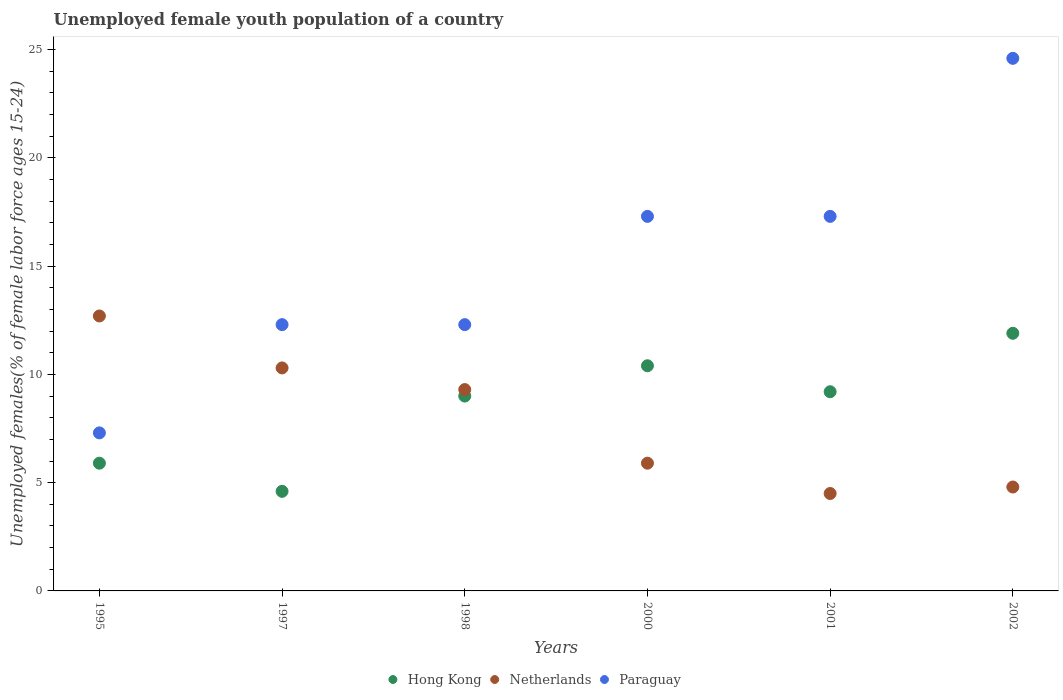How many different coloured dotlines are there?
Give a very brief answer. 3. Is the number of dotlines equal to the number of legend labels?
Give a very brief answer. Yes. Across all years, what is the maximum percentage of unemployed female youth population in Netherlands?
Your answer should be compact. 12.7. Across all years, what is the minimum percentage of unemployed female youth population in Hong Kong?
Make the answer very short. 4.6. What is the total percentage of unemployed female youth population in Hong Kong in the graph?
Provide a short and direct response. 51. What is the difference between the percentage of unemployed female youth population in Hong Kong in 1998 and that in 2001?
Provide a short and direct response. -0.2. What is the difference between the percentage of unemployed female youth population in Paraguay in 1997 and the percentage of unemployed female youth population in Hong Kong in 2001?
Make the answer very short. 3.1. What is the average percentage of unemployed female youth population in Hong Kong per year?
Keep it short and to the point. 8.5. In the year 1998, what is the difference between the percentage of unemployed female youth population in Hong Kong and percentage of unemployed female youth population in Paraguay?
Keep it short and to the point. -3.3. What is the ratio of the percentage of unemployed female youth population in Paraguay in 1998 to that in 2001?
Your answer should be very brief. 0.71. Is the percentage of unemployed female youth population in Hong Kong in 1998 less than that in 2001?
Your answer should be compact. Yes. Is the difference between the percentage of unemployed female youth population in Hong Kong in 1998 and 2000 greater than the difference between the percentage of unemployed female youth population in Paraguay in 1998 and 2000?
Keep it short and to the point. Yes. What is the difference between the highest and the second highest percentage of unemployed female youth population in Paraguay?
Offer a terse response. 7.3. What is the difference between the highest and the lowest percentage of unemployed female youth population in Hong Kong?
Your response must be concise. 7.3. In how many years, is the percentage of unemployed female youth population in Hong Kong greater than the average percentage of unemployed female youth population in Hong Kong taken over all years?
Provide a succinct answer. 4. Is the sum of the percentage of unemployed female youth population in Paraguay in 2001 and 2002 greater than the maximum percentage of unemployed female youth population in Netherlands across all years?
Give a very brief answer. Yes. Is it the case that in every year, the sum of the percentage of unemployed female youth population in Paraguay and percentage of unemployed female youth population in Hong Kong  is greater than the percentage of unemployed female youth population in Netherlands?
Your response must be concise. Yes. Is the percentage of unemployed female youth population in Hong Kong strictly greater than the percentage of unemployed female youth population in Paraguay over the years?
Offer a very short reply. No. How many years are there in the graph?
Provide a succinct answer. 6. Does the graph contain any zero values?
Provide a succinct answer. No. Does the graph contain grids?
Provide a short and direct response. No. Where does the legend appear in the graph?
Make the answer very short. Bottom center. How many legend labels are there?
Keep it short and to the point. 3. How are the legend labels stacked?
Give a very brief answer. Horizontal. What is the title of the graph?
Provide a succinct answer. Unemployed female youth population of a country. What is the label or title of the X-axis?
Provide a succinct answer. Years. What is the label or title of the Y-axis?
Your response must be concise. Unemployed females(% of female labor force ages 15-24). What is the Unemployed females(% of female labor force ages 15-24) in Hong Kong in 1995?
Keep it short and to the point. 5.9. What is the Unemployed females(% of female labor force ages 15-24) in Netherlands in 1995?
Provide a short and direct response. 12.7. What is the Unemployed females(% of female labor force ages 15-24) in Paraguay in 1995?
Your answer should be compact. 7.3. What is the Unemployed females(% of female labor force ages 15-24) of Hong Kong in 1997?
Your response must be concise. 4.6. What is the Unemployed females(% of female labor force ages 15-24) in Netherlands in 1997?
Keep it short and to the point. 10.3. What is the Unemployed females(% of female labor force ages 15-24) of Paraguay in 1997?
Provide a succinct answer. 12.3. What is the Unemployed females(% of female labor force ages 15-24) in Netherlands in 1998?
Your answer should be compact. 9.3. What is the Unemployed females(% of female labor force ages 15-24) of Paraguay in 1998?
Offer a terse response. 12.3. What is the Unemployed females(% of female labor force ages 15-24) in Hong Kong in 2000?
Your answer should be very brief. 10.4. What is the Unemployed females(% of female labor force ages 15-24) of Netherlands in 2000?
Your response must be concise. 5.9. What is the Unemployed females(% of female labor force ages 15-24) of Paraguay in 2000?
Your answer should be compact. 17.3. What is the Unemployed females(% of female labor force ages 15-24) of Hong Kong in 2001?
Make the answer very short. 9.2. What is the Unemployed females(% of female labor force ages 15-24) of Netherlands in 2001?
Keep it short and to the point. 4.5. What is the Unemployed females(% of female labor force ages 15-24) of Paraguay in 2001?
Make the answer very short. 17.3. What is the Unemployed females(% of female labor force ages 15-24) in Hong Kong in 2002?
Your response must be concise. 11.9. What is the Unemployed females(% of female labor force ages 15-24) in Netherlands in 2002?
Make the answer very short. 4.8. What is the Unemployed females(% of female labor force ages 15-24) in Paraguay in 2002?
Offer a terse response. 24.6. Across all years, what is the maximum Unemployed females(% of female labor force ages 15-24) of Hong Kong?
Give a very brief answer. 11.9. Across all years, what is the maximum Unemployed females(% of female labor force ages 15-24) in Netherlands?
Provide a succinct answer. 12.7. Across all years, what is the maximum Unemployed females(% of female labor force ages 15-24) in Paraguay?
Give a very brief answer. 24.6. Across all years, what is the minimum Unemployed females(% of female labor force ages 15-24) in Hong Kong?
Make the answer very short. 4.6. Across all years, what is the minimum Unemployed females(% of female labor force ages 15-24) in Netherlands?
Provide a succinct answer. 4.5. Across all years, what is the minimum Unemployed females(% of female labor force ages 15-24) of Paraguay?
Give a very brief answer. 7.3. What is the total Unemployed females(% of female labor force ages 15-24) of Hong Kong in the graph?
Your answer should be compact. 51. What is the total Unemployed females(% of female labor force ages 15-24) in Netherlands in the graph?
Give a very brief answer. 47.5. What is the total Unemployed females(% of female labor force ages 15-24) in Paraguay in the graph?
Offer a very short reply. 91.1. What is the difference between the Unemployed females(% of female labor force ages 15-24) in Hong Kong in 1995 and that in 1997?
Your answer should be compact. 1.3. What is the difference between the Unemployed females(% of female labor force ages 15-24) in Netherlands in 1995 and that in 1997?
Make the answer very short. 2.4. What is the difference between the Unemployed females(% of female labor force ages 15-24) of Paraguay in 1995 and that in 1997?
Offer a very short reply. -5. What is the difference between the Unemployed females(% of female labor force ages 15-24) in Hong Kong in 1995 and that in 1998?
Give a very brief answer. -3.1. What is the difference between the Unemployed females(% of female labor force ages 15-24) in Hong Kong in 1995 and that in 2000?
Your response must be concise. -4.5. What is the difference between the Unemployed females(% of female labor force ages 15-24) of Netherlands in 1995 and that in 2000?
Keep it short and to the point. 6.8. What is the difference between the Unemployed females(% of female labor force ages 15-24) in Hong Kong in 1995 and that in 2001?
Keep it short and to the point. -3.3. What is the difference between the Unemployed females(% of female labor force ages 15-24) of Hong Kong in 1995 and that in 2002?
Your answer should be very brief. -6. What is the difference between the Unemployed females(% of female labor force ages 15-24) of Netherlands in 1995 and that in 2002?
Provide a succinct answer. 7.9. What is the difference between the Unemployed females(% of female labor force ages 15-24) in Paraguay in 1995 and that in 2002?
Offer a very short reply. -17.3. What is the difference between the Unemployed females(% of female labor force ages 15-24) in Hong Kong in 1997 and that in 1998?
Offer a very short reply. -4.4. What is the difference between the Unemployed females(% of female labor force ages 15-24) of Hong Kong in 1997 and that in 2001?
Offer a very short reply. -4.6. What is the difference between the Unemployed females(% of female labor force ages 15-24) in Netherlands in 1998 and that in 2000?
Your answer should be very brief. 3.4. What is the difference between the Unemployed females(% of female labor force ages 15-24) in Paraguay in 1998 and that in 2000?
Ensure brevity in your answer.  -5. What is the difference between the Unemployed females(% of female labor force ages 15-24) in Hong Kong in 1998 and that in 2001?
Offer a very short reply. -0.2. What is the difference between the Unemployed females(% of female labor force ages 15-24) in Netherlands in 1998 and that in 2001?
Make the answer very short. 4.8. What is the difference between the Unemployed females(% of female labor force ages 15-24) in Paraguay in 1998 and that in 2002?
Provide a short and direct response. -12.3. What is the difference between the Unemployed females(% of female labor force ages 15-24) in Hong Kong in 2000 and that in 2001?
Keep it short and to the point. 1.2. What is the difference between the Unemployed females(% of female labor force ages 15-24) in Paraguay in 2000 and that in 2001?
Provide a succinct answer. 0. What is the difference between the Unemployed females(% of female labor force ages 15-24) of Hong Kong in 2000 and that in 2002?
Provide a short and direct response. -1.5. What is the difference between the Unemployed females(% of female labor force ages 15-24) in Netherlands in 2000 and that in 2002?
Provide a short and direct response. 1.1. What is the difference between the Unemployed females(% of female labor force ages 15-24) in Paraguay in 2000 and that in 2002?
Your response must be concise. -7.3. What is the difference between the Unemployed females(% of female labor force ages 15-24) of Hong Kong in 1995 and the Unemployed females(% of female labor force ages 15-24) of Netherlands in 1997?
Make the answer very short. -4.4. What is the difference between the Unemployed females(% of female labor force ages 15-24) of Hong Kong in 1995 and the Unemployed females(% of female labor force ages 15-24) of Paraguay in 1997?
Your response must be concise. -6.4. What is the difference between the Unemployed females(% of female labor force ages 15-24) of Hong Kong in 1995 and the Unemployed females(% of female labor force ages 15-24) of Netherlands in 1998?
Ensure brevity in your answer.  -3.4. What is the difference between the Unemployed females(% of female labor force ages 15-24) of Hong Kong in 1995 and the Unemployed females(% of female labor force ages 15-24) of Paraguay in 1998?
Your response must be concise. -6.4. What is the difference between the Unemployed females(% of female labor force ages 15-24) of Hong Kong in 1995 and the Unemployed females(% of female labor force ages 15-24) of Paraguay in 2000?
Your response must be concise. -11.4. What is the difference between the Unemployed females(% of female labor force ages 15-24) of Hong Kong in 1995 and the Unemployed females(% of female labor force ages 15-24) of Paraguay in 2001?
Make the answer very short. -11.4. What is the difference between the Unemployed females(% of female labor force ages 15-24) of Hong Kong in 1995 and the Unemployed females(% of female labor force ages 15-24) of Paraguay in 2002?
Offer a terse response. -18.7. What is the difference between the Unemployed females(% of female labor force ages 15-24) in Netherlands in 1995 and the Unemployed females(% of female labor force ages 15-24) in Paraguay in 2002?
Offer a terse response. -11.9. What is the difference between the Unemployed females(% of female labor force ages 15-24) of Hong Kong in 1997 and the Unemployed females(% of female labor force ages 15-24) of Netherlands in 2000?
Make the answer very short. -1.3. What is the difference between the Unemployed females(% of female labor force ages 15-24) in Hong Kong in 1997 and the Unemployed females(% of female labor force ages 15-24) in Netherlands in 2001?
Your response must be concise. 0.1. What is the difference between the Unemployed females(% of female labor force ages 15-24) of Hong Kong in 1997 and the Unemployed females(% of female labor force ages 15-24) of Paraguay in 2001?
Your response must be concise. -12.7. What is the difference between the Unemployed females(% of female labor force ages 15-24) of Netherlands in 1997 and the Unemployed females(% of female labor force ages 15-24) of Paraguay in 2001?
Provide a succinct answer. -7. What is the difference between the Unemployed females(% of female labor force ages 15-24) of Hong Kong in 1997 and the Unemployed females(% of female labor force ages 15-24) of Netherlands in 2002?
Ensure brevity in your answer.  -0.2. What is the difference between the Unemployed females(% of female labor force ages 15-24) of Netherlands in 1997 and the Unemployed females(% of female labor force ages 15-24) of Paraguay in 2002?
Ensure brevity in your answer.  -14.3. What is the difference between the Unemployed females(% of female labor force ages 15-24) in Hong Kong in 1998 and the Unemployed females(% of female labor force ages 15-24) in Netherlands in 2000?
Provide a succinct answer. 3.1. What is the difference between the Unemployed females(% of female labor force ages 15-24) in Hong Kong in 1998 and the Unemployed females(% of female labor force ages 15-24) in Paraguay in 2000?
Offer a terse response. -8.3. What is the difference between the Unemployed females(% of female labor force ages 15-24) of Netherlands in 1998 and the Unemployed females(% of female labor force ages 15-24) of Paraguay in 2000?
Offer a very short reply. -8. What is the difference between the Unemployed females(% of female labor force ages 15-24) of Hong Kong in 1998 and the Unemployed females(% of female labor force ages 15-24) of Netherlands in 2001?
Provide a short and direct response. 4.5. What is the difference between the Unemployed females(% of female labor force ages 15-24) in Netherlands in 1998 and the Unemployed females(% of female labor force ages 15-24) in Paraguay in 2001?
Your answer should be very brief. -8. What is the difference between the Unemployed females(% of female labor force ages 15-24) in Hong Kong in 1998 and the Unemployed females(% of female labor force ages 15-24) in Paraguay in 2002?
Your answer should be compact. -15.6. What is the difference between the Unemployed females(% of female labor force ages 15-24) in Netherlands in 1998 and the Unemployed females(% of female labor force ages 15-24) in Paraguay in 2002?
Make the answer very short. -15.3. What is the difference between the Unemployed females(% of female labor force ages 15-24) of Hong Kong in 2000 and the Unemployed females(% of female labor force ages 15-24) of Netherlands in 2001?
Your response must be concise. 5.9. What is the difference between the Unemployed females(% of female labor force ages 15-24) of Netherlands in 2000 and the Unemployed females(% of female labor force ages 15-24) of Paraguay in 2001?
Keep it short and to the point. -11.4. What is the difference between the Unemployed females(% of female labor force ages 15-24) in Hong Kong in 2000 and the Unemployed females(% of female labor force ages 15-24) in Paraguay in 2002?
Offer a terse response. -14.2. What is the difference between the Unemployed females(% of female labor force ages 15-24) of Netherlands in 2000 and the Unemployed females(% of female labor force ages 15-24) of Paraguay in 2002?
Offer a terse response. -18.7. What is the difference between the Unemployed females(% of female labor force ages 15-24) of Hong Kong in 2001 and the Unemployed females(% of female labor force ages 15-24) of Paraguay in 2002?
Give a very brief answer. -15.4. What is the difference between the Unemployed females(% of female labor force ages 15-24) in Netherlands in 2001 and the Unemployed females(% of female labor force ages 15-24) in Paraguay in 2002?
Give a very brief answer. -20.1. What is the average Unemployed females(% of female labor force ages 15-24) of Netherlands per year?
Offer a very short reply. 7.92. What is the average Unemployed females(% of female labor force ages 15-24) in Paraguay per year?
Keep it short and to the point. 15.18. In the year 1995, what is the difference between the Unemployed females(% of female labor force ages 15-24) in Hong Kong and Unemployed females(% of female labor force ages 15-24) in Paraguay?
Give a very brief answer. -1.4. In the year 1997, what is the difference between the Unemployed females(% of female labor force ages 15-24) in Hong Kong and Unemployed females(% of female labor force ages 15-24) in Netherlands?
Your answer should be compact. -5.7. In the year 1997, what is the difference between the Unemployed females(% of female labor force ages 15-24) in Hong Kong and Unemployed females(% of female labor force ages 15-24) in Paraguay?
Your response must be concise. -7.7. In the year 1997, what is the difference between the Unemployed females(% of female labor force ages 15-24) of Netherlands and Unemployed females(% of female labor force ages 15-24) of Paraguay?
Your answer should be compact. -2. In the year 1998, what is the difference between the Unemployed females(% of female labor force ages 15-24) in Hong Kong and Unemployed females(% of female labor force ages 15-24) in Netherlands?
Make the answer very short. -0.3. In the year 1998, what is the difference between the Unemployed females(% of female labor force ages 15-24) in Netherlands and Unemployed females(% of female labor force ages 15-24) in Paraguay?
Your answer should be compact. -3. In the year 2000, what is the difference between the Unemployed females(% of female labor force ages 15-24) in Hong Kong and Unemployed females(% of female labor force ages 15-24) in Netherlands?
Keep it short and to the point. 4.5. In the year 2001, what is the difference between the Unemployed females(% of female labor force ages 15-24) of Hong Kong and Unemployed females(% of female labor force ages 15-24) of Netherlands?
Your answer should be compact. 4.7. In the year 2002, what is the difference between the Unemployed females(% of female labor force ages 15-24) in Hong Kong and Unemployed females(% of female labor force ages 15-24) in Netherlands?
Your response must be concise. 7.1. In the year 2002, what is the difference between the Unemployed females(% of female labor force ages 15-24) of Hong Kong and Unemployed females(% of female labor force ages 15-24) of Paraguay?
Offer a very short reply. -12.7. In the year 2002, what is the difference between the Unemployed females(% of female labor force ages 15-24) in Netherlands and Unemployed females(% of female labor force ages 15-24) in Paraguay?
Provide a succinct answer. -19.8. What is the ratio of the Unemployed females(% of female labor force ages 15-24) of Hong Kong in 1995 to that in 1997?
Keep it short and to the point. 1.28. What is the ratio of the Unemployed females(% of female labor force ages 15-24) in Netherlands in 1995 to that in 1997?
Provide a short and direct response. 1.23. What is the ratio of the Unemployed females(% of female labor force ages 15-24) in Paraguay in 1995 to that in 1997?
Your response must be concise. 0.59. What is the ratio of the Unemployed females(% of female labor force ages 15-24) of Hong Kong in 1995 to that in 1998?
Ensure brevity in your answer.  0.66. What is the ratio of the Unemployed females(% of female labor force ages 15-24) of Netherlands in 1995 to that in 1998?
Your answer should be compact. 1.37. What is the ratio of the Unemployed females(% of female labor force ages 15-24) in Paraguay in 1995 to that in 1998?
Your answer should be very brief. 0.59. What is the ratio of the Unemployed females(% of female labor force ages 15-24) of Hong Kong in 1995 to that in 2000?
Your response must be concise. 0.57. What is the ratio of the Unemployed females(% of female labor force ages 15-24) of Netherlands in 1995 to that in 2000?
Your response must be concise. 2.15. What is the ratio of the Unemployed females(% of female labor force ages 15-24) in Paraguay in 1995 to that in 2000?
Your answer should be very brief. 0.42. What is the ratio of the Unemployed females(% of female labor force ages 15-24) of Hong Kong in 1995 to that in 2001?
Your response must be concise. 0.64. What is the ratio of the Unemployed females(% of female labor force ages 15-24) of Netherlands in 1995 to that in 2001?
Provide a succinct answer. 2.82. What is the ratio of the Unemployed females(% of female labor force ages 15-24) of Paraguay in 1995 to that in 2001?
Offer a very short reply. 0.42. What is the ratio of the Unemployed females(% of female labor force ages 15-24) in Hong Kong in 1995 to that in 2002?
Your answer should be very brief. 0.5. What is the ratio of the Unemployed females(% of female labor force ages 15-24) of Netherlands in 1995 to that in 2002?
Provide a short and direct response. 2.65. What is the ratio of the Unemployed females(% of female labor force ages 15-24) of Paraguay in 1995 to that in 2002?
Keep it short and to the point. 0.3. What is the ratio of the Unemployed females(% of female labor force ages 15-24) of Hong Kong in 1997 to that in 1998?
Provide a succinct answer. 0.51. What is the ratio of the Unemployed females(% of female labor force ages 15-24) in Netherlands in 1997 to that in 1998?
Provide a short and direct response. 1.11. What is the ratio of the Unemployed females(% of female labor force ages 15-24) in Hong Kong in 1997 to that in 2000?
Provide a succinct answer. 0.44. What is the ratio of the Unemployed females(% of female labor force ages 15-24) of Netherlands in 1997 to that in 2000?
Keep it short and to the point. 1.75. What is the ratio of the Unemployed females(% of female labor force ages 15-24) of Paraguay in 1997 to that in 2000?
Make the answer very short. 0.71. What is the ratio of the Unemployed females(% of female labor force ages 15-24) of Netherlands in 1997 to that in 2001?
Provide a short and direct response. 2.29. What is the ratio of the Unemployed females(% of female labor force ages 15-24) of Paraguay in 1997 to that in 2001?
Your answer should be very brief. 0.71. What is the ratio of the Unemployed females(% of female labor force ages 15-24) of Hong Kong in 1997 to that in 2002?
Provide a succinct answer. 0.39. What is the ratio of the Unemployed females(% of female labor force ages 15-24) of Netherlands in 1997 to that in 2002?
Your answer should be compact. 2.15. What is the ratio of the Unemployed females(% of female labor force ages 15-24) of Hong Kong in 1998 to that in 2000?
Make the answer very short. 0.87. What is the ratio of the Unemployed females(% of female labor force ages 15-24) of Netherlands in 1998 to that in 2000?
Give a very brief answer. 1.58. What is the ratio of the Unemployed females(% of female labor force ages 15-24) in Paraguay in 1998 to that in 2000?
Your response must be concise. 0.71. What is the ratio of the Unemployed females(% of female labor force ages 15-24) of Hong Kong in 1998 to that in 2001?
Provide a short and direct response. 0.98. What is the ratio of the Unemployed females(% of female labor force ages 15-24) in Netherlands in 1998 to that in 2001?
Keep it short and to the point. 2.07. What is the ratio of the Unemployed females(% of female labor force ages 15-24) of Paraguay in 1998 to that in 2001?
Ensure brevity in your answer.  0.71. What is the ratio of the Unemployed females(% of female labor force ages 15-24) in Hong Kong in 1998 to that in 2002?
Offer a very short reply. 0.76. What is the ratio of the Unemployed females(% of female labor force ages 15-24) of Netherlands in 1998 to that in 2002?
Your response must be concise. 1.94. What is the ratio of the Unemployed females(% of female labor force ages 15-24) of Hong Kong in 2000 to that in 2001?
Ensure brevity in your answer.  1.13. What is the ratio of the Unemployed females(% of female labor force ages 15-24) in Netherlands in 2000 to that in 2001?
Offer a terse response. 1.31. What is the ratio of the Unemployed females(% of female labor force ages 15-24) of Hong Kong in 2000 to that in 2002?
Provide a short and direct response. 0.87. What is the ratio of the Unemployed females(% of female labor force ages 15-24) of Netherlands in 2000 to that in 2002?
Provide a short and direct response. 1.23. What is the ratio of the Unemployed females(% of female labor force ages 15-24) in Paraguay in 2000 to that in 2002?
Your answer should be compact. 0.7. What is the ratio of the Unemployed females(% of female labor force ages 15-24) in Hong Kong in 2001 to that in 2002?
Make the answer very short. 0.77. What is the ratio of the Unemployed females(% of female labor force ages 15-24) in Netherlands in 2001 to that in 2002?
Offer a very short reply. 0.94. What is the ratio of the Unemployed females(% of female labor force ages 15-24) in Paraguay in 2001 to that in 2002?
Make the answer very short. 0.7. What is the difference between the highest and the second highest Unemployed females(% of female labor force ages 15-24) in Paraguay?
Make the answer very short. 7.3. What is the difference between the highest and the lowest Unemployed females(% of female labor force ages 15-24) in Hong Kong?
Your answer should be compact. 7.3. What is the difference between the highest and the lowest Unemployed females(% of female labor force ages 15-24) of Paraguay?
Make the answer very short. 17.3. 